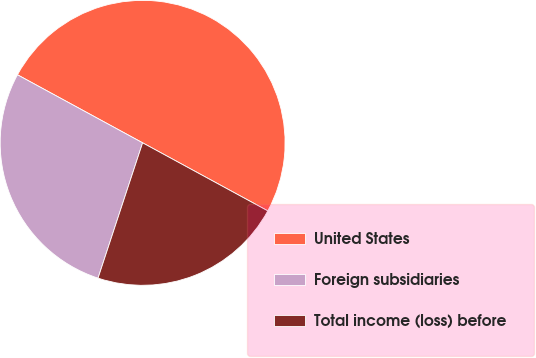<chart> <loc_0><loc_0><loc_500><loc_500><pie_chart><fcel>United States<fcel>Foreign subsidiaries<fcel>Total income (loss) before<nl><fcel>50.0%<fcel>27.86%<fcel>22.14%<nl></chart> 